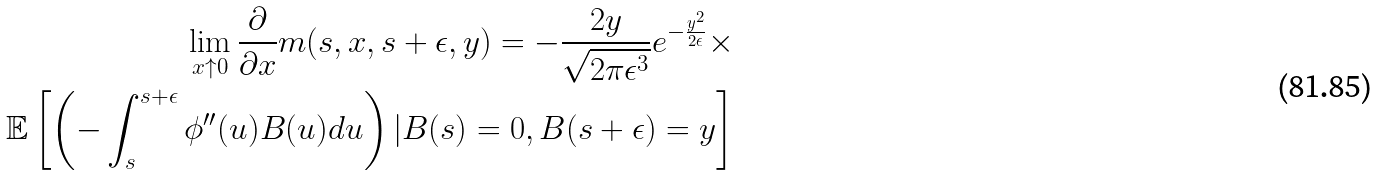Convert formula to latex. <formula><loc_0><loc_0><loc_500><loc_500>\lim _ { x \uparrow 0 } \frac { \partial } { \partial x } m ( s , x , s + \epsilon , y ) = - \frac { 2 y } { \sqrt { 2 \pi \epsilon ^ { 3 } } } e ^ { - \frac { y ^ { 2 } } { 2 \epsilon } } \times \\ \mathbb { E } \left [ \left ( - \int _ { s } ^ { s + \epsilon } \phi ^ { \prime \prime } ( u ) B ( u ) d u \right ) | B ( s ) = 0 , B ( s + \epsilon ) = y \right ]</formula> 